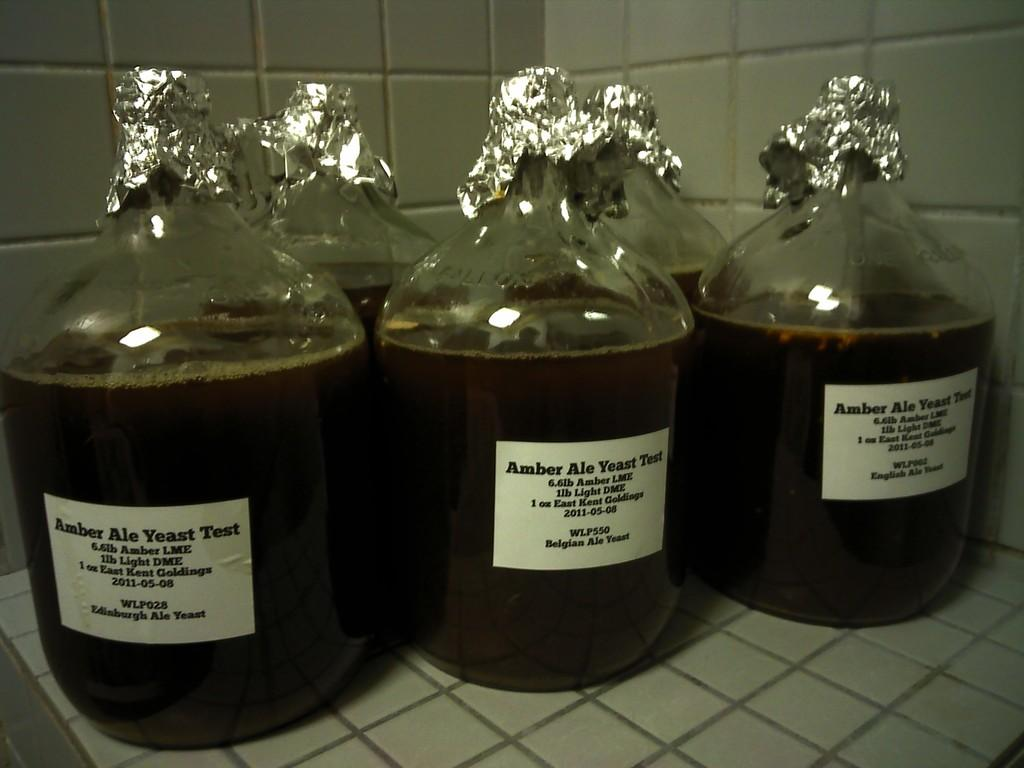Provide a one-sentence caption for the provided image. 3 identical bottles of the drink Amber Ale Yeast. 